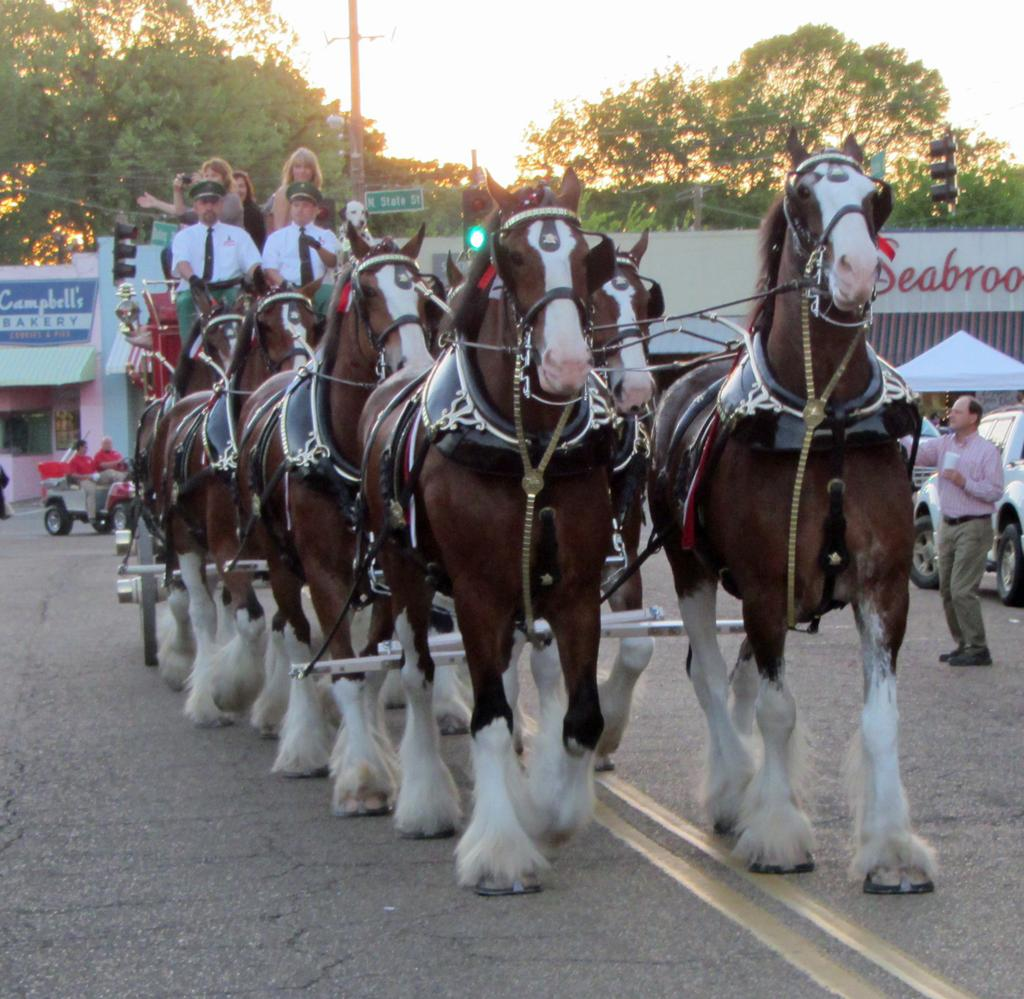Who or what can be seen in the image? There are people and horses in the image. What are the people and horses associated with in the image? They are associated with a cart in the image. What else is present on the road in the image? There are vehicles on the road in the image. Can you describe any structures or objects in the image? There is a pole, boards, and stores in the image. What can be seen in the background of the image? There are trees and sky visible in the background of the image. What type of cap is the thing wearing in the image? There is no "thing" wearing a cap in the image, as the subjects are people and horses, and neither of them wears a cap. 